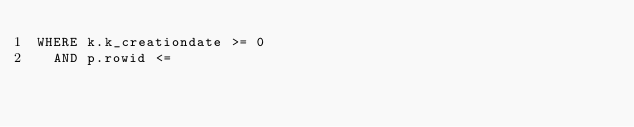Convert code to text. <code><loc_0><loc_0><loc_500><loc_500><_SQL_>WHERE k.k_creationdate >= 0
  AND p.rowid <=
</code> 